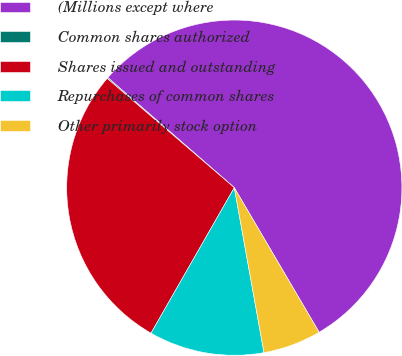Convert chart to OTSL. <chart><loc_0><loc_0><loc_500><loc_500><pie_chart><fcel>(Millions except where<fcel>Common shares authorized<fcel>Shares issued and outstanding<fcel>Repurchases of common shares<fcel>Other primarily stock option<nl><fcel>55.16%<fcel>0.1%<fcel>28.02%<fcel>11.11%<fcel>5.61%<nl></chart> 